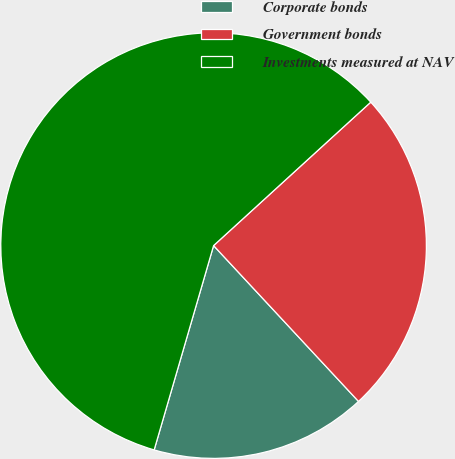<chart> <loc_0><loc_0><loc_500><loc_500><pie_chart><fcel>Corporate bonds<fcel>Government bonds<fcel>Investments measured at NAV<nl><fcel>16.43%<fcel>24.85%<fcel>58.72%<nl></chart> 